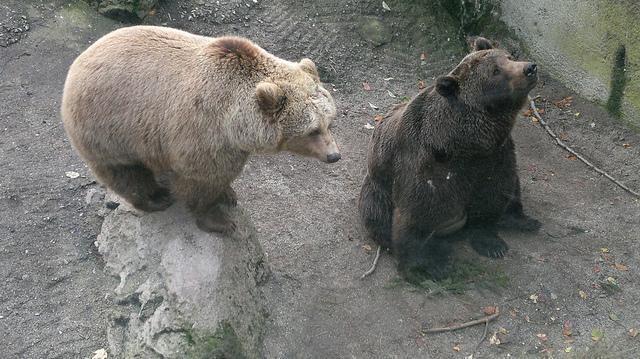How many bears are there?
Give a very brief answer. 2. How many bears can be seen?
Give a very brief answer. 2. How many blue cars are there?
Give a very brief answer. 0. 